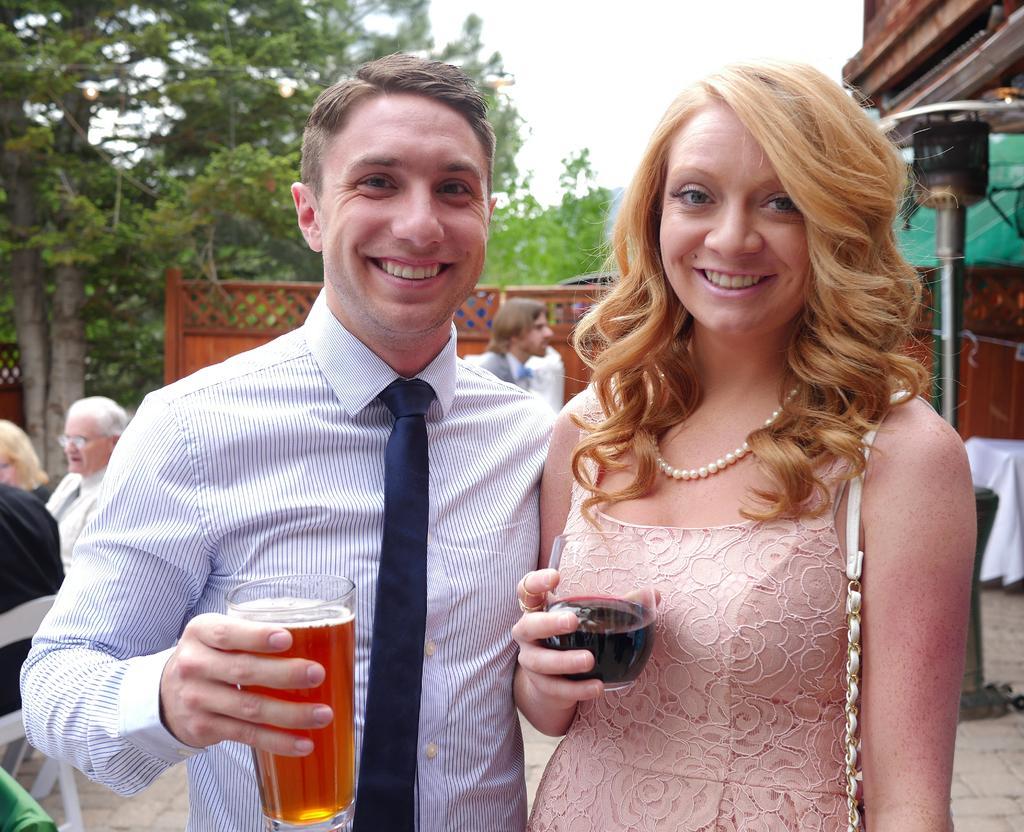Describe this image in one or two sentences. In front of the picture, we see the woman and the men are standing. Both of them are holding the glasses containing liquid in their hands. They are smiling and they might be posing for the photo. On the left side, we see people are sitting on the chairs.. Behind them, we see a man is standing. Behind him, we see a wooden wall. On the right side, we see a pole and a table which is covered with the white cloth. We see the roof of the building. There are trees in the background. At the top, we see the sky. 